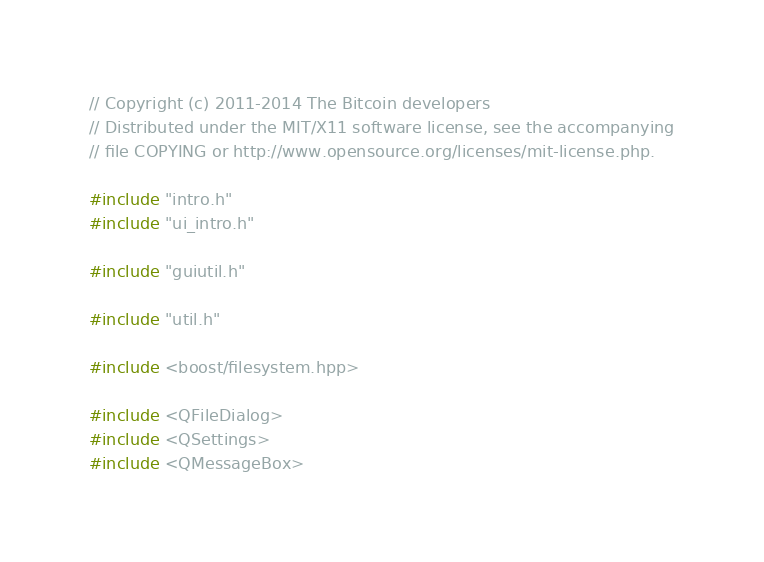<code> <loc_0><loc_0><loc_500><loc_500><_C++_>// Copyright (c) 2011-2014 The Bitcoin developers
// Distributed under the MIT/X11 software license, see the accompanying
// file COPYING or http://www.opensource.org/licenses/mit-license.php.

#include "intro.h"
#include "ui_intro.h"

#include "guiutil.h"

#include "util.h"

#include <boost/filesystem.hpp>

#include <QFileDialog>
#include <QSettings>
#include <QMessageBox>
</code> 